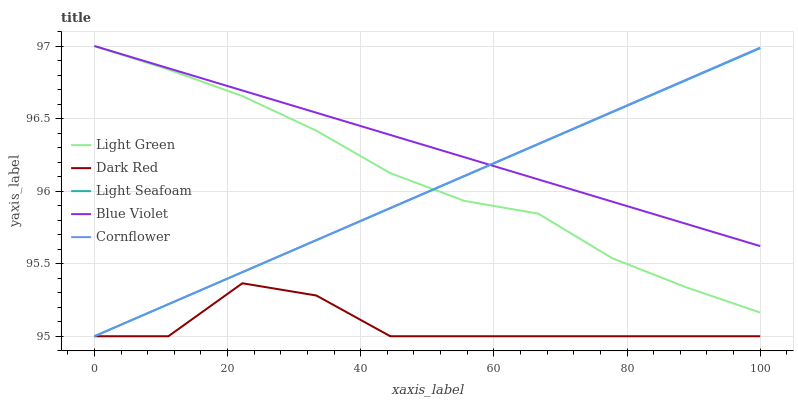Does Dark Red have the minimum area under the curve?
Answer yes or no. Yes. Does Blue Violet have the maximum area under the curve?
Answer yes or no. Yes. Does Light Seafoam have the minimum area under the curve?
Answer yes or no. No. Does Light Seafoam have the maximum area under the curve?
Answer yes or no. No. Is Cornflower the smoothest?
Answer yes or no. Yes. Is Dark Red the roughest?
Answer yes or no. Yes. Is Light Seafoam the smoothest?
Answer yes or no. No. Is Light Seafoam the roughest?
Answer yes or no. No. Does Dark Red have the lowest value?
Answer yes or no. Yes. Does Blue Violet have the lowest value?
Answer yes or no. No. Does Light Green have the highest value?
Answer yes or no. Yes. Does Light Seafoam have the highest value?
Answer yes or no. No. Is Dark Red less than Blue Violet?
Answer yes or no. Yes. Is Light Green greater than Dark Red?
Answer yes or no. Yes. Does Light Seafoam intersect Cornflower?
Answer yes or no. Yes. Is Light Seafoam less than Cornflower?
Answer yes or no. No. Is Light Seafoam greater than Cornflower?
Answer yes or no. No. Does Dark Red intersect Blue Violet?
Answer yes or no. No. 